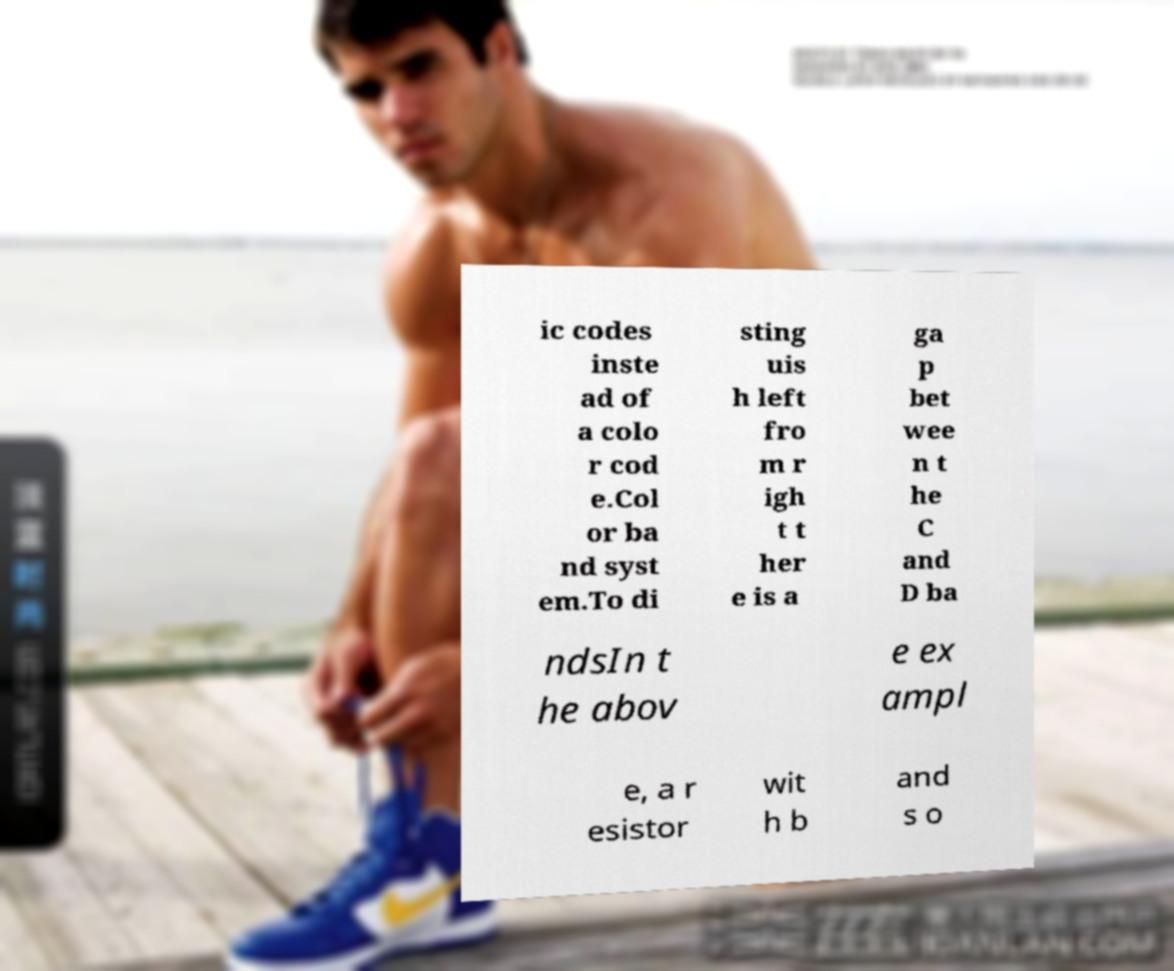Please read and relay the text visible in this image. What does it say? ic codes inste ad of a colo r cod e.Col or ba nd syst em.To di sting uis h left fro m r igh t t her e is a ga p bet wee n t he C and D ba ndsIn t he abov e ex ampl e, a r esistor wit h b and s o 